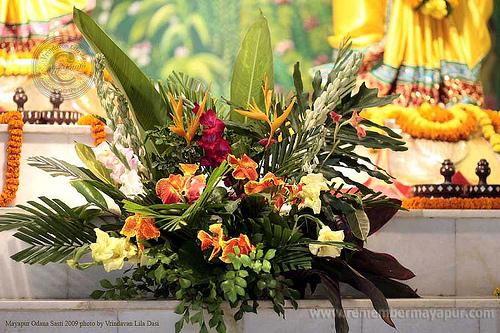Is there any purple flowers in the bouquet?
Concise answer only. No. Are these flowers outdoors?
Give a very brief answer. No. Do these flowers have a scent?
Keep it brief. Yes. 